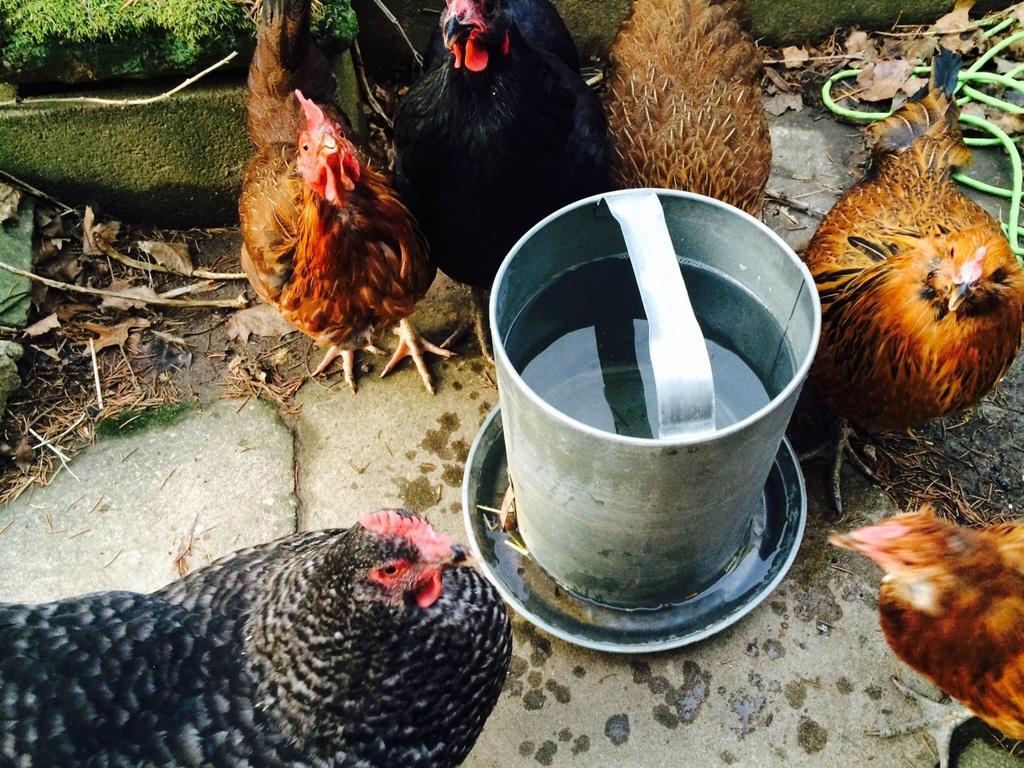Can you describe this image briefly? This picture seems to be clicked outside. In the center there is an object containing water is placed on the ground and we can see the group of hens standing on the ground and we can see the dry leaves and the green grass and some other objects. 